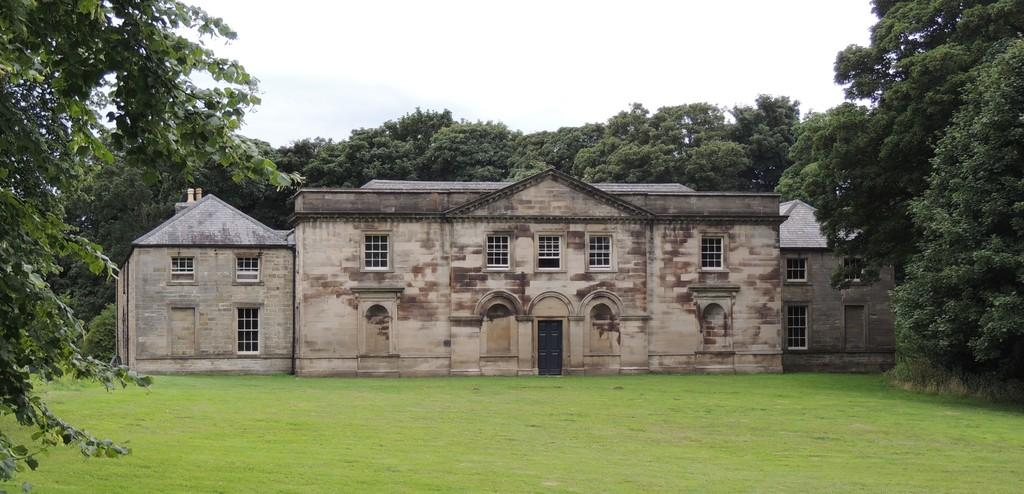What type of structure can be seen in the image? There is a building in the image. What type of vegetation is visible at the bottom of the image? Grass is visible at the bottom of the image. What can be seen in the background of the image? There are many trees in the background of the image. What is visible at the top of the image? The sky is visible at the top of the image. What can be observed in the sky? Clouds are present in the sky. What type of toy can be seen in the image? There is no toy present in the image. What sound can be heard coming from the trees in the image? There is no sound present in the image, as it is a still photograph. 